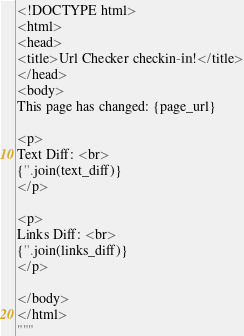<code> <loc_0><loc_0><loc_500><loc_500><_Python_><!DOCTYPE html>
<html>
<head>
<title>Url Checker checkin-in!</title>
</head>
<body>
This page has changed: {page_url}

<p>
Text Diff: <br>
{''.join(text_diff)}
</p>

<p>
Links Diff: <br>
{''.join(links_diff)}
</p>

</body>
</html>
"""
</code> 